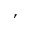Convert formula to latex. <formula><loc_0><loc_0><loc_500><loc_500>,</formula> 